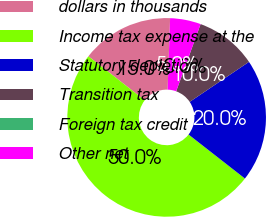<chart> <loc_0><loc_0><loc_500><loc_500><pie_chart><fcel>dollars in thousands<fcel>Income tax expense at the<fcel>Statutory depletion<fcel>Transition tax<fcel>Foreign tax credit<fcel>Other net<nl><fcel>15.0%<fcel>50.0%<fcel>20.0%<fcel>10.0%<fcel>0.0%<fcel>5.0%<nl></chart> 